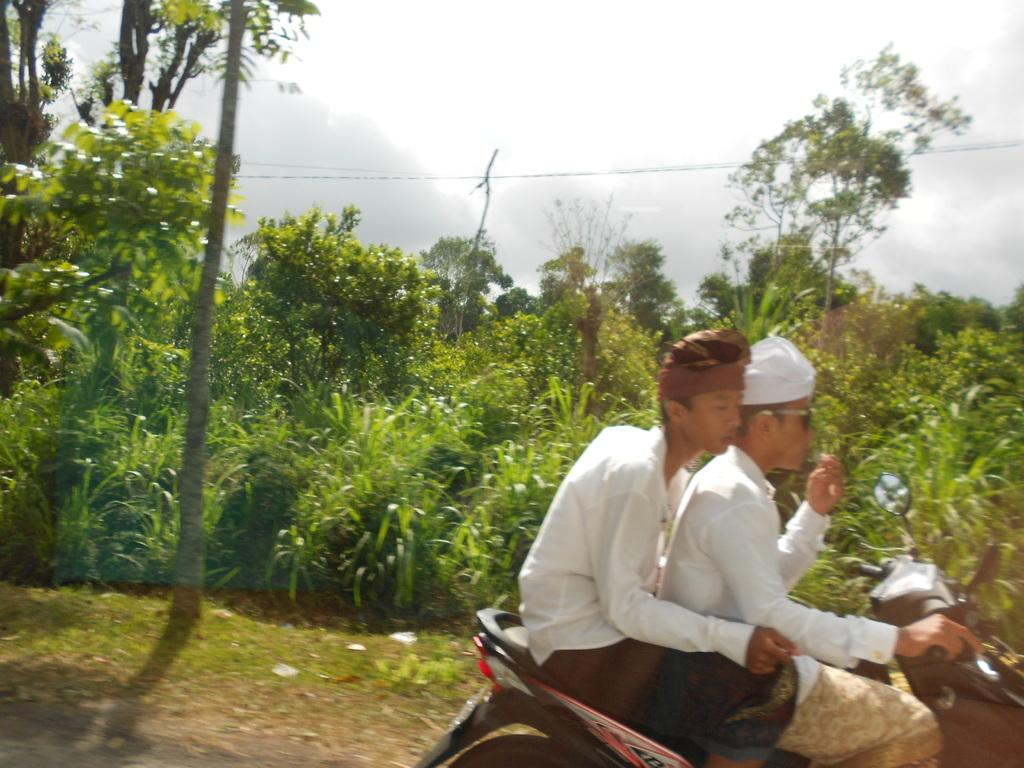How many people are in the image? There are two men in the image. What are the men doing in the image? The men are sitting on a scooty. What type of vegetation can be seen in the image? There are plants and trees in the image. What type of fear can be seen on the men's faces in the image? There is no indication of fear on the men's faces in the image. What type of ship can be seen in the image? There is no ship present in the image. 